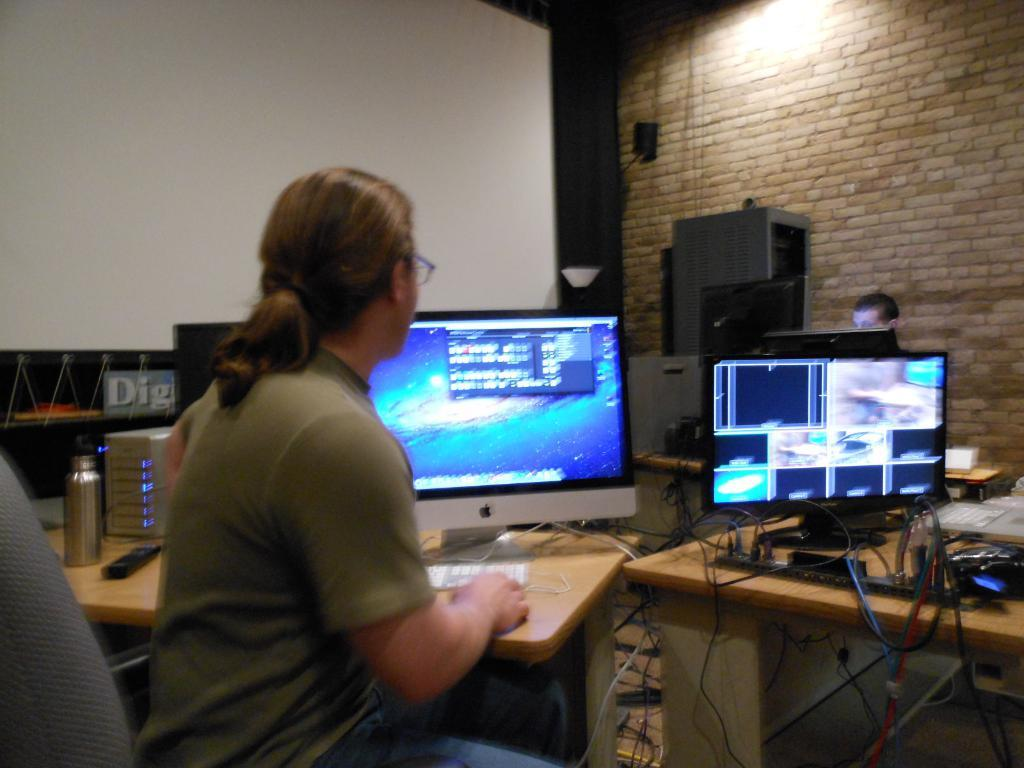<image>
Render a clear and concise summary of the photo. a person sits in front of computers and the word DIG to the left 